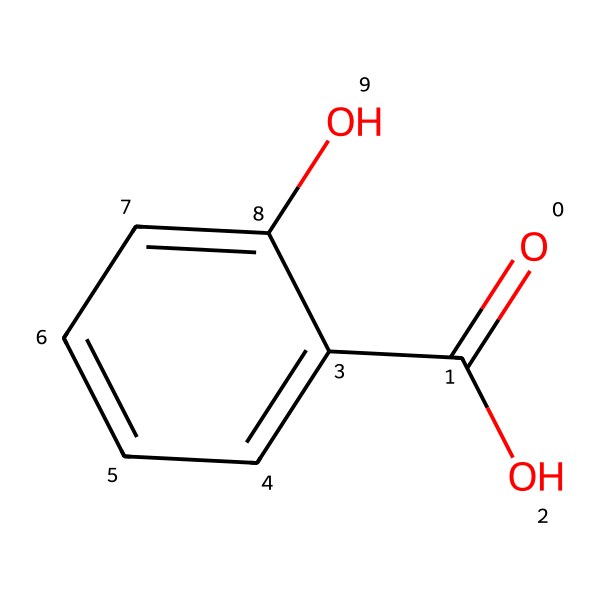What is the functional group present in salicylic acid? The structure of salicylic acid contains a hydroxyl group (-OH) and a carboxylic acid group (-COOH) that classify it as a phenol.
Answer: phenol How many carbon atoms are in salicylic acid? By interpreting the SMILES, we can identify six carbon atoms from the aromatic ring and one from the carboxylic acid group, totaling seven.
Answer: seven What type of acid is salicylic acid classified as? Salicylic acid has a carboxylic acid functional group, indicating it is a weak organic acid.
Answer: carboxylic What is the effect of salicylic acid on the skin? Salicylic acid acts as an exfoliant and helps to unclog pores, making it effective for acne treatment.
Answer: exfoliant How many hydroxyl groups are present in salicylic acid? The structure shows one hydroxyl group attached directly to the benzene ring, indicating one -OH group is present.
Answer: one What is the molecular formula of salicylic acid? By counting the atoms from the SMILES representation, the composed formula is C7H6O3, representing its molecular structure.
Answer: C7H6O3 Does salicylic acid have a phenolic structure? The presence of a hydroxyl group attached to an aromatic ring confirms that salicylic acid has a phenolic structure.
Answer: yes 